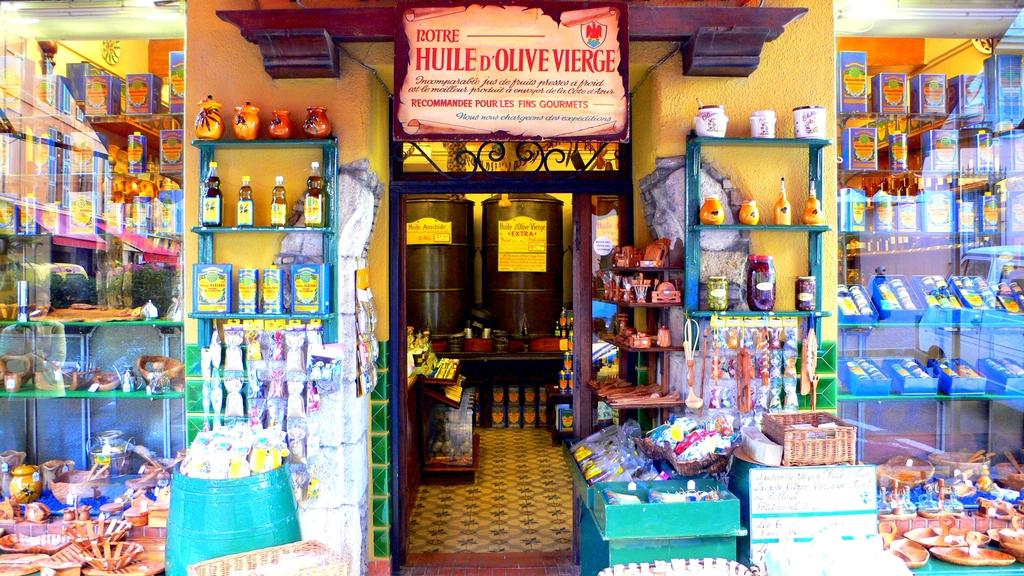<image>
Present a compact description of the photo's key features. On the top shelf are three jars, the left most jar is for olives. 